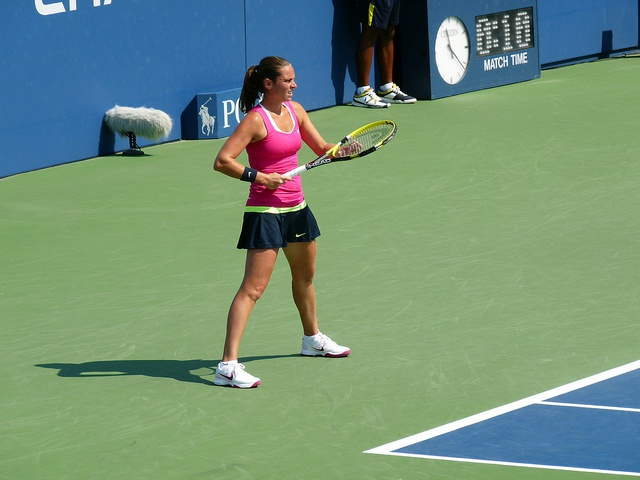Describe the objects in this image and their specific colors. I can see people in blue, black, maroon, salmon, and tan tones, people in blue, black, maroon, white, and gray tones, clock in blue, gray, black, purple, and darkgray tones, tennis racket in blue, olive, darkgray, and black tones, and clock in blue, white, darkgray, and gray tones in this image. 